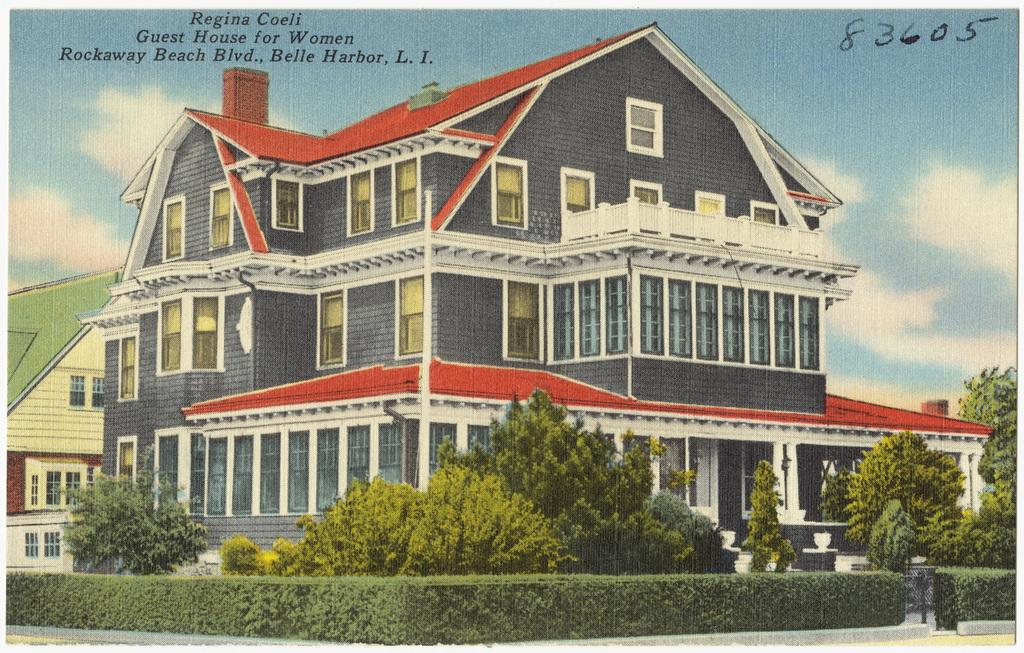What is the main subject of the image? The image contains a picture. What type of structures can be seen in the picture? There are buildings in the picture. What type of vegetation is present in the picture? Bushes, house plants, and trees are visible in the picture. What architectural features can be seen in the picture? There are windows and a chimney in the picture. What is visible in the background of the picture? The sky is visible in the picture, with clouds present. What type of copper material is used in the construction of the buildings in the image? There is no mention of copper being used in the construction of the buildings in the image. What scientific experiments are being conducted in the picture? There is no indication of any scientific experiments being conducted in the image. 